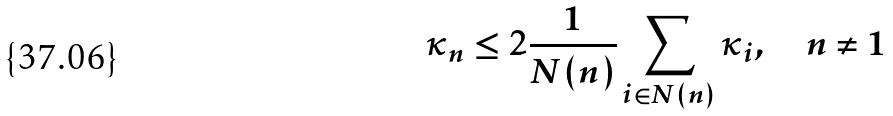<formula> <loc_0><loc_0><loc_500><loc_500>\kappa _ { n } \leq 2 \frac { 1 } { N ( n ) } \sum _ { i \in N ( n ) } \kappa _ { i } , \quad n \ne 1</formula> 